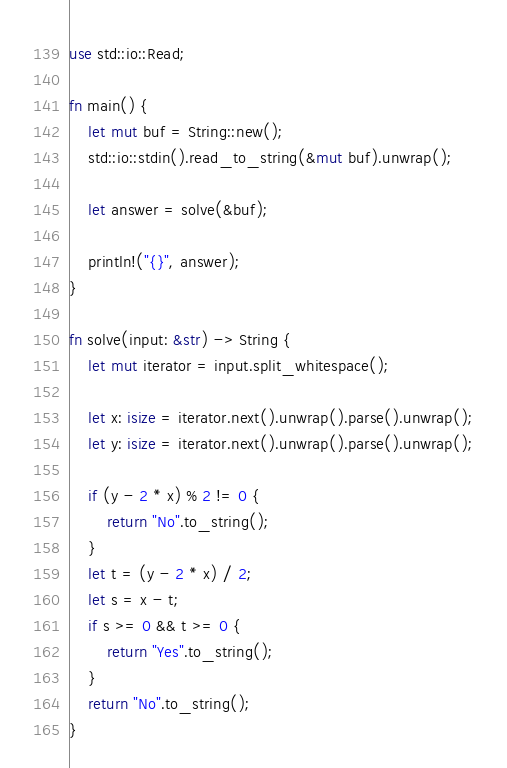Convert code to text. <code><loc_0><loc_0><loc_500><loc_500><_Rust_>use std::io::Read;

fn main() {
    let mut buf = String::new();
    std::io::stdin().read_to_string(&mut buf).unwrap();

    let answer = solve(&buf);

    println!("{}", answer);
}

fn solve(input: &str) -> String {
    let mut iterator = input.split_whitespace();

    let x: isize = iterator.next().unwrap().parse().unwrap();
    let y: isize = iterator.next().unwrap().parse().unwrap();

    if (y - 2 * x) % 2 != 0 {
        return "No".to_string();
    }
    let t = (y - 2 * x) / 2;
    let s = x - t;
    if s >= 0 && t >= 0 {
        return "Yes".to_string();
    }
    return "No".to_string();
}
</code> 